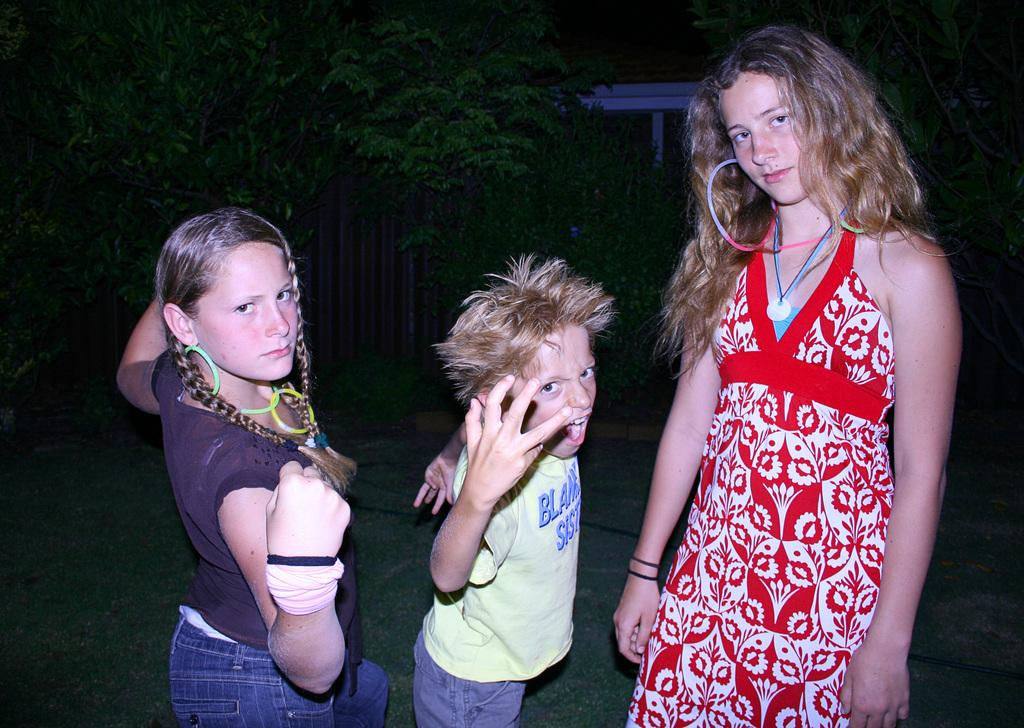How many children are present in the image? There are three children in the image: two girls and a boy. Can you describe the object in the background of the image? Unfortunately, the facts provided do not give any details about the object in the background. What type of natural environment is visible in the image? There are trees in the background of the image, indicating a natural environment. What purpose does the knife serve in the image? There is no knife present in the image, so it cannot serve any purpose in this context. 